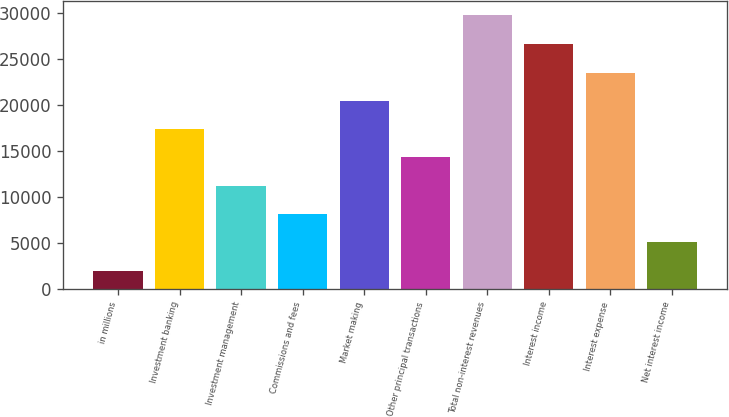<chart> <loc_0><loc_0><loc_500><loc_500><bar_chart><fcel>in millions<fcel>Investment banking<fcel>Investment management<fcel>Commissions and fees<fcel>Market making<fcel>Other principal transactions<fcel>Total non-interest revenues<fcel>Interest income<fcel>Interest expense<fcel>Net interest income<nl><fcel>2017<fcel>17373.5<fcel>11230.9<fcel>8159.6<fcel>20444.8<fcel>14302.2<fcel>29798<fcel>26587.4<fcel>23516.1<fcel>5088.3<nl></chart> 